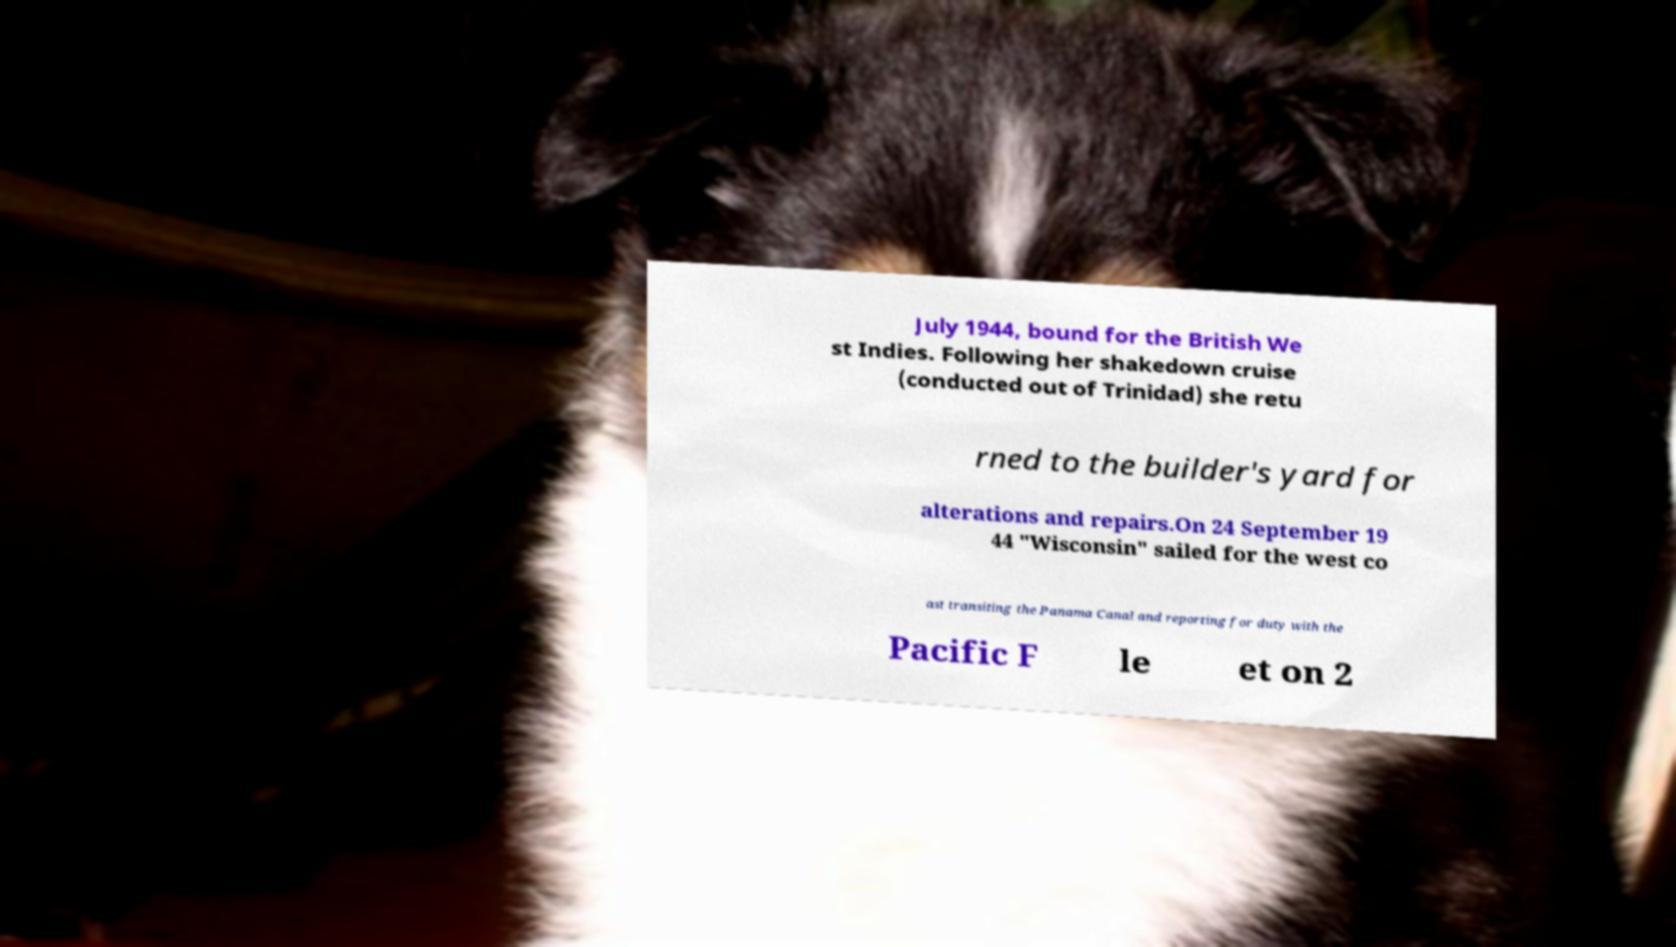There's text embedded in this image that I need extracted. Can you transcribe it verbatim? July 1944, bound for the British We st Indies. Following her shakedown cruise (conducted out of Trinidad) she retu rned to the builder's yard for alterations and repairs.On 24 September 19 44 "Wisconsin" sailed for the west co ast transiting the Panama Canal and reporting for duty with the Pacific F le et on 2 